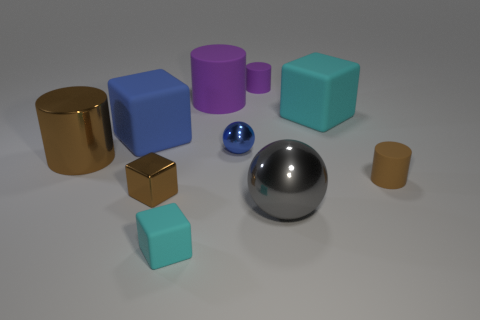How many things are either big cyan shiny objects or big brown things? There are a total of four things that match the criteria in the image: three big brown objects and one big cyan shiny cube. 